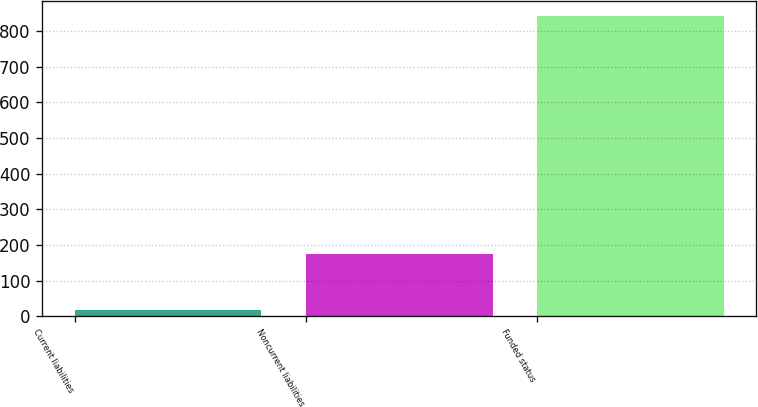<chart> <loc_0><loc_0><loc_500><loc_500><bar_chart><fcel>Current liabilities<fcel>Noncurrent liabilities<fcel>Funded status<nl><fcel>18<fcel>174<fcel>843<nl></chart> 